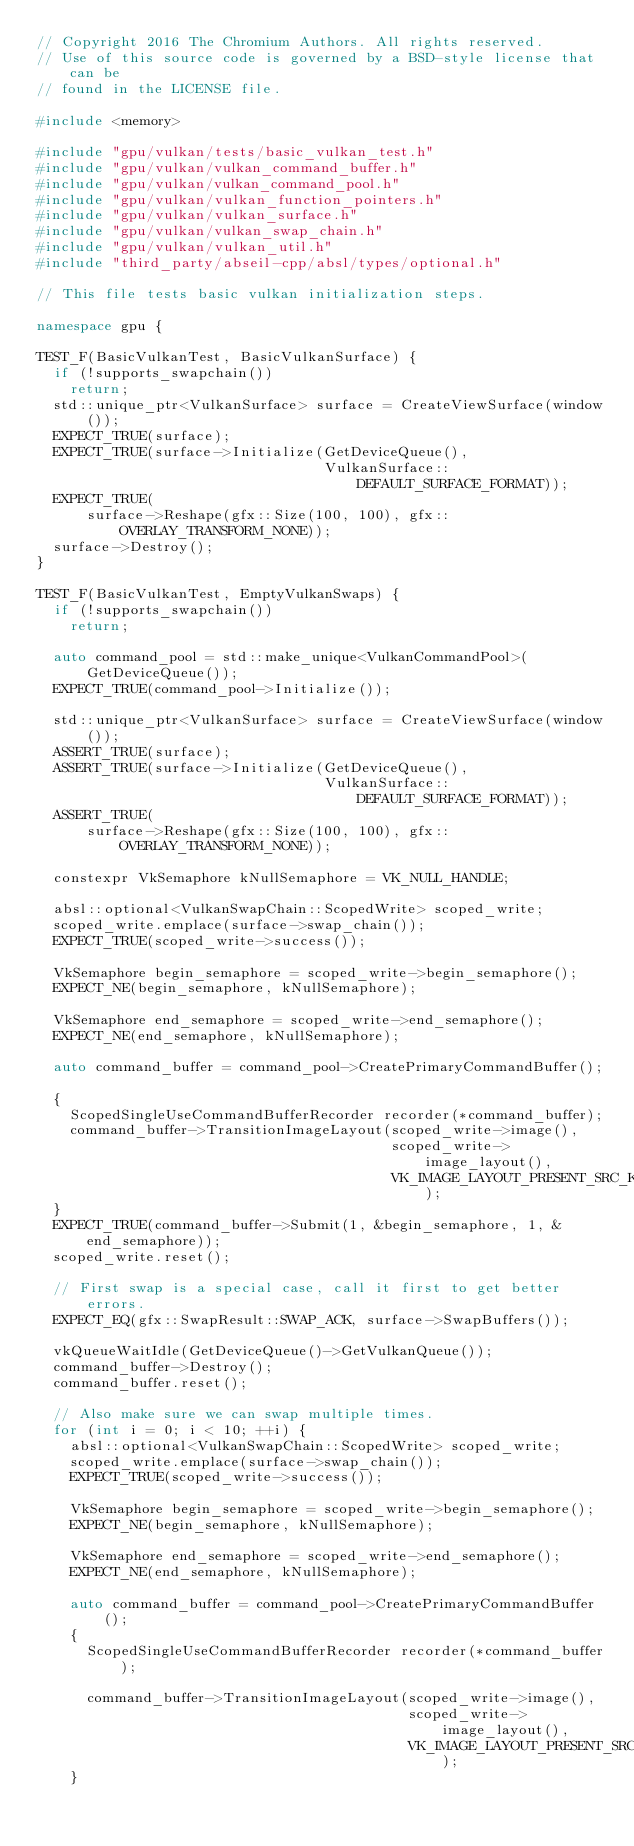Convert code to text. <code><loc_0><loc_0><loc_500><loc_500><_C++_>// Copyright 2016 The Chromium Authors. All rights reserved.
// Use of this source code is governed by a BSD-style license that can be
// found in the LICENSE file.

#include <memory>

#include "gpu/vulkan/tests/basic_vulkan_test.h"
#include "gpu/vulkan/vulkan_command_buffer.h"
#include "gpu/vulkan/vulkan_command_pool.h"
#include "gpu/vulkan/vulkan_function_pointers.h"
#include "gpu/vulkan/vulkan_surface.h"
#include "gpu/vulkan/vulkan_swap_chain.h"
#include "gpu/vulkan/vulkan_util.h"
#include "third_party/abseil-cpp/absl/types/optional.h"

// This file tests basic vulkan initialization steps.

namespace gpu {

TEST_F(BasicVulkanTest, BasicVulkanSurface) {
  if (!supports_swapchain())
    return;
  std::unique_ptr<VulkanSurface> surface = CreateViewSurface(window());
  EXPECT_TRUE(surface);
  EXPECT_TRUE(surface->Initialize(GetDeviceQueue(),
                                  VulkanSurface::DEFAULT_SURFACE_FORMAT));
  EXPECT_TRUE(
      surface->Reshape(gfx::Size(100, 100), gfx::OVERLAY_TRANSFORM_NONE));
  surface->Destroy();
}

TEST_F(BasicVulkanTest, EmptyVulkanSwaps) {
  if (!supports_swapchain())
    return;

  auto command_pool = std::make_unique<VulkanCommandPool>(GetDeviceQueue());
  EXPECT_TRUE(command_pool->Initialize());

  std::unique_ptr<VulkanSurface> surface = CreateViewSurface(window());
  ASSERT_TRUE(surface);
  ASSERT_TRUE(surface->Initialize(GetDeviceQueue(),
                                  VulkanSurface::DEFAULT_SURFACE_FORMAT));
  ASSERT_TRUE(
      surface->Reshape(gfx::Size(100, 100), gfx::OVERLAY_TRANSFORM_NONE));

  constexpr VkSemaphore kNullSemaphore = VK_NULL_HANDLE;

  absl::optional<VulkanSwapChain::ScopedWrite> scoped_write;
  scoped_write.emplace(surface->swap_chain());
  EXPECT_TRUE(scoped_write->success());

  VkSemaphore begin_semaphore = scoped_write->begin_semaphore();
  EXPECT_NE(begin_semaphore, kNullSemaphore);

  VkSemaphore end_semaphore = scoped_write->end_semaphore();
  EXPECT_NE(end_semaphore, kNullSemaphore);

  auto command_buffer = command_pool->CreatePrimaryCommandBuffer();

  {
    ScopedSingleUseCommandBufferRecorder recorder(*command_buffer);
    command_buffer->TransitionImageLayout(scoped_write->image(),
                                          scoped_write->image_layout(),
                                          VK_IMAGE_LAYOUT_PRESENT_SRC_KHR);
  }
  EXPECT_TRUE(command_buffer->Submit(1, &begin_semaphore, 1, &end_semaphore));
  scoped_write.reset();

  // First swap is a special case, call it first to get better errors.
  EXPECT_EQ(gfx::SwapResult::SWAP_ACK, surface->SwapBuffers());

  vkQueueWaitIdle(GetDeviceQueue()->GetVulkanQueue());
  command_buffer->Destroy();
  command_buffer.reset();

  // Also make sure we can swap multiple times.
  for (int i = 0; i < 10; ++i) {
    absl::optional<VulkanSwapChain::ScopedWrite> scoped_write;
    scoped_write.emplace(surface->swap_chain());
    EXPECT_TRUE(scoped_write->success());

    VkSemaphore begin_semaphore = scoped_write->begin_semaphore();
    EXPECT_NE(begin_semaphore, kNullSemaphore);

    VkSemaphore end_semaphore = scoped_write->end_semaphore();
    EXPECT_NE(end_semaphore, kNullSemaphore);

    auto command_buffer = command_pool->CreatePrimaryCommandBuffer();
    {
      ScopedSingleUseCommandBufferRecorder recorder(*command_buffer);

      command_buffer->TransitionImageLayout(scoped_write->image(),
                                            scoped_write->image_layout(),
                                            VK_IMAGE_LAYOUT_PRESENT_SRC_KHR);
    }</code> 